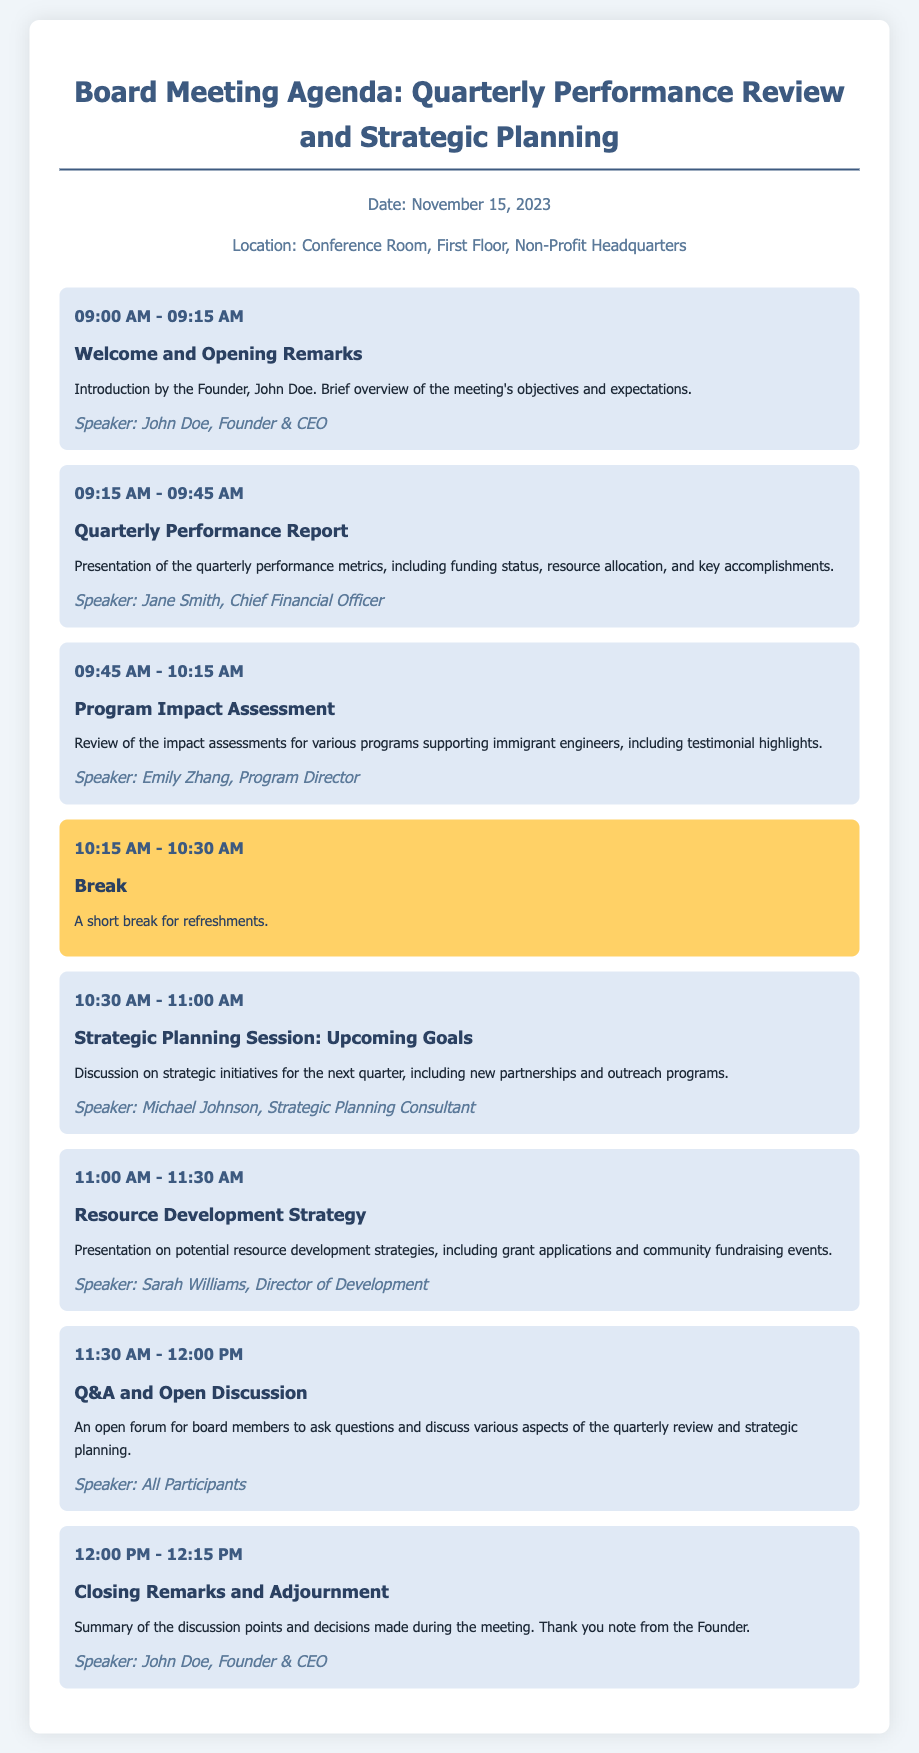What is the date of the meeting? The date of the meeting is specified in the document.
Answer: November 15, 2023 Who is the speaker for the Quarterly Performance Report? The speaker is mentioned in the agenda item for the Quarterly Performance Report.
Answer: Jane Smith What time does the Q&A and Open Discussion start? The time for the Q&A session is listed in the agenda.
Answer: 11:30 AM What is the topic of the first session? The first session's topic is mentioned in the agenda section.
Answer: Welcome and Opening Remarks Which session follows directly after the break? The agenda specifies the session that takes place after the break.
Answer: Strategic Planning Session: Upcoming Goals How long is the break scheduled for? The duration of the break is stated in the agenda details.
Answer: 15 minutes Who is providing the closing remarks? The speaker for the closing remarks is indicated in the closing session details.
Answer: John Doe What is the main focus of the Program Impact Assessment session? The details of the session describe what will be discussed.
Answer: Impact assessments for various programs supporting immigrant engineers What will be discussed in the Resource Development Strategy presentation? The agenda provides an overview of what will be covered in this session.
Answer: Potential resource development strategies 